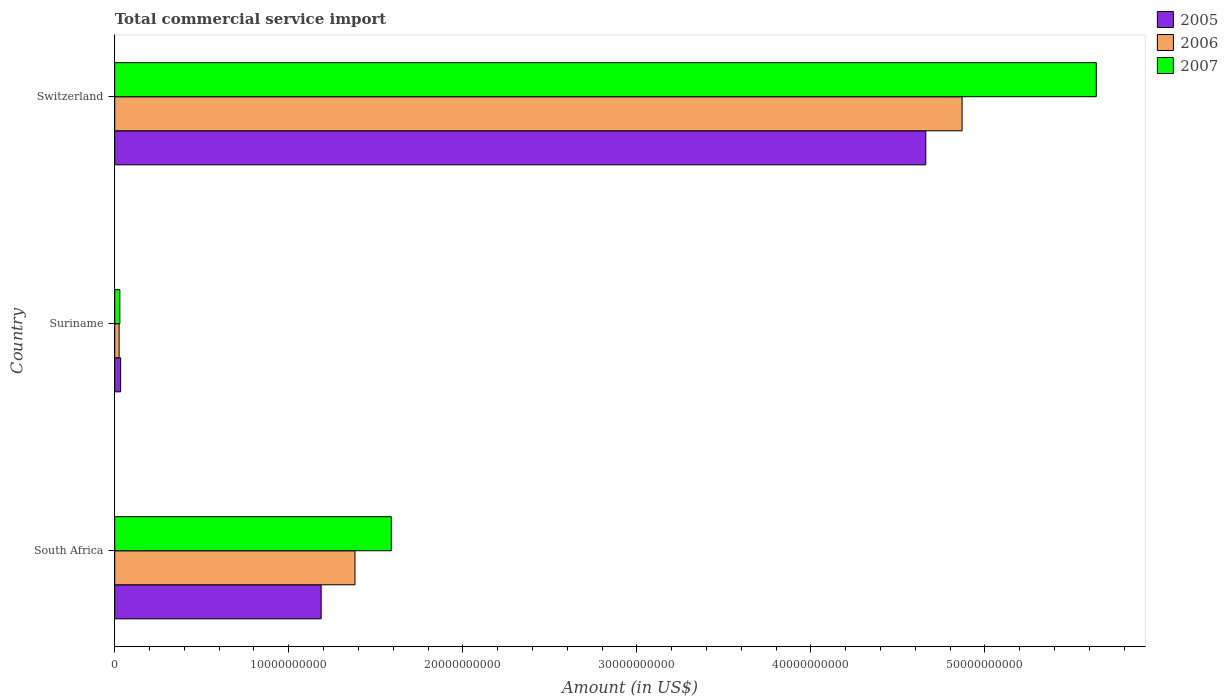How many groups of bars are there?
Your response must be concise. 3. Are the number of bars per tick equal to the number of legend labels?
Keep it short and to the point. Yes. Are the number of bars on each tick of the Y-axis equal?
Give a very brief answer. Yes. How many bars are there on the 2nd tick from the top?
Provide a short and direct response. 3. What is the label of the 1st group of bars from the top?
Give a very brief answer. Switzerland. What is the total commercial service import in 2007 in Suriname?
Your response must be concise. 2.93e+08. Across all countries, what is the maximum total commercial service import in 2006?
Offer a very short reply. 4.87e+1. Across all countries, what is the minimum total commercial service import in 2005?
Your response must be concise. 3.39e+08. In which country was the total commercial service import in 2007 maximum?
Give a very brief answer. Switzerland. In which country was the total commercial service import in 2007 minimum?
Provide a short and direct response. Suriname. What is the total total commercial service import in 2005 in the graph?
Your response must be concise. 5.88e+1. What is the difference between the total commercial service import in 2007 in South Africa and that in Switzerland?
Your response must be concise. -4.05e+1. What is the difference between the total commercial service import in 2005 in Suriname and the total commercial service import in 2006 in Switzerland?
Offer a terse response. -4.83e+1. What is the average total commercial service import in 2005 per country?
Keep it short and to the point. 1.96e+1. What is the difference between the total commercial service import in 2005 and total commercial service import in 2007 in South Africa?
Offer a terse response. -4.03e+09. What is the ratio of the total commercial service import in 2005 in South Africa to that in Suriname?
Offer a very short reply. 34.96. Is the difference between the total commercial service import in 2005 in South Africa and Switzerland greater than the difference between the total commercial service import in 2007 in South Africa and Switzerland?
Ensure brevity in your answer.  Yes. What is the difference between the highest and the second highest total commercial service import in 2007?
Your answer should be very brief. 4.05e+1. What is the difference between the highest and the lowest total commercial service import in 2006?
Your answer should be compact. 4.84e+1. What does the 3rd bar from the bottom in South Africa represents?
Give a very brief answer. 2007. How many bars are there?
Offer a terse response. 9. Are all the bars in the graph horizontal?
Provide a succinct answer. Yes. What is the difference between two consecutive major ticks on the X-axis?
Provide a short and direct response. 1.00e+1. Does the graph contain any zero values?
Your answer should be very brief. No. Does the graph contain grids?
Offer a very short reply. No. Where does the legend appear in the graph?
Your answer should be very brief. Top right. How many legend labels are there?
Your answer should be very brief. 3. What is the title of the graph?
Your answer should be very brief. Total commercial service import. Does "1989" appear as one of the legend labels in the graph?
Offer a very short reply. No. What is the label or title of the Y-axis?
Provide a succinct answer. Country. What is the Amount (in US$) of 2005 in South Africa?
Provide a short and direct response. 1.19e+1. What is the Amount (in US$) in 2006 in South Africa?
Your answer should be very brief. 1.38e+1. What is the Amount (in US$) of 2007 in South Africa?
Keep it short and to the point. 1.59e+1. What is the Amount (in US$) in 2005 in Suriname?
Your answer should be compact. 3.39e+08. What is the Amount (in US$) of 2006 in Suriname?
Your answer should be very brief. 2.51e+08. What is the Amount (in US$) of 2007 in Suriname?
Make the answer very short. 2.93e+08. What is the Amount (in US$) of 2005 in Switzerland?
Your answer should be compact. 4.66e+1. What is the Amount (in US$) in 2006 in Switzerland?
Ensure brevity in your answer.  4.87e+1. What is the Amount (in US$) in 2007 in Switzerland?
Provide a short and direct response. 5.64e+1. Across all countries, what is the maximum Amount (in US$) of 2005?
Offer a terse response. 4.66e+1. Across all countries, what is the maximum Amount (in US$) of 2006?
Your answer should be very brief. 4.87e+1. Across all countries, what is the maximum Amount (in US$) in 2007?
Provide a short and direct response. 5.64e+1. Across all countries, what is the minimum Amount (in US$) of 2005?
Provide a short and direct response. 3.39e+08. Across all countries, what is the minimum Amount (in US$) of 2006?
Offer a terse response. 2.51e+08. Across all countries, what is the minimum Amount (in US$) in 2007?
Make the answer very short. 2.93e+08. What is the total Amount (in US$) of 2005 in the graph?
Offer a very short reply. 5.88e+1. What is the total Amount (in US$) of 2006 in the graph?
Keep it short and to the point. 6.27e+1. What is the total Amount (in US$) of 2007 in the graph?
Your answer should be compact. 7.26e+1. What is the difference between the Amount (in US$) in 2005 in South Africa and that in Suriname?
Your response must be concise. 1.15e+1. What is the difference between the Amount (in US$) in 2006 in South Africa and that in Suriname?
Provide a short and direct response. 1.36e+1. What is the difference between the Amount (in US$) in 2007 in South Africa and that in Suriname?
Keep it short and to the point. 1.56e+1. What is the difference between the Amount (in US$) in 2005 in South Africa and that in Switzerland?
Ensure brevity in your answer.  -3.47e+1. What is the difference between the Amount (in US$) of 2006 in South Africa and that in Switzerland?
Offer a very short reply. -3.49e+1. What is the difference between the Amount (in US$) in 2007 in South Africa and that in Switzerland?
Give a very brief answer. -4.05e+1. What is the difference between the Amount (in US$) in 2005 in Suriname and that in Switzerland?
Offer a very short reply. -4.63e+1. What is the difference between the Amount (in US$) of 2006 in Suriname and that in Switzerland?
Your answer should be very brief. -4.84e+1. What is the difference between the Amount (in US$) of 2007 in Suriname and that in Switzerland?
Keep it short and to the point. -5.61e+1. What is the difference between the Amount (in US$) in 2005 in South Africa and the Amount (in US$) in 2006 in Suriname?
Ensure brevity in your answer.  1.16e+1. What is the difference between the Amount (in US$) of 2005 in South Africa and the Amount (in US$) of 2007 in Suriname?
Keep it short and to the point. 1.16e+1. What is the difference between the Amount (in US$) of 2006 in South Africa and the Amount (in US$) of 2007 in Suriname?
Make the answer very short. 1.35e+1. What is the difference between the Amount (in US$) of 2005 in South Africa and the Amount (in US$) of 2006 in Switzerland?
Ensure brevity in your answer.  -3.68e+1. What is the difference between the Amount (in US$) in 2005 in South Africa and the Amount (in US$) in 2007 in Switzerland?
Make the answer very short. -4.45e+1. What is the difference between the Amount (in US$) of 2006 in South Africa and the Amount (in US$) of 2007 in Switzerland?
Your response must be concise. -4.26e+1. What is the difference between the Amount (in US$) of 2005 in Suriname and the Amount (in US$) of 2006 in Switzerland?
Provide a short and direct response. -4.83e+1. What is the difference between the Amount (in US$) in 2005 in Suriname and the Amount (in US$) in 2007 in Switzerland?
Keep it short and to the point. -5.61e+1. What is the difference between the Amount (in US$) in 2006 in Suriname and the Amount (in US$) in 2007 in Switzerland?
Provide a short and direct response. -5.61e+1. What is the average Amount (in US$) of 2005 per country?
Keep it short and to the point. 1.96e+1. What is the average Amount (in US$) in 2006 per country?
Your answer should be very brief. 2.09e+1. What is the average Amount (in US$) of 2007 per country?
Offer a terse response. 2.42e+1. What is the difference between the Amount (in US$) of 2005 and Amount (in US$) of 2006 in South Africa?
Your answer should be very brief. -1.94e+09. What is the difference between the Amount (in US$) in 2005 and Amount (in US$) in 2007 in South Africa?
Offer a terse response. -4.03e+09. What is the difference between the Amount (in US$) in 2006 and Amount (in US$) in 2007 in South Africa?
Ensure brevity in your answer.  -2.09e+09. What is the difference between the Amount (in US$) in 2005 and Amount (in US$) in 2006 in Suriname?
Offer a very short reply. 8.83e+07. What is the difference between the Amount (in US$) in 2005 and Amount (in US$) in 2007 in Suriname?
Offer a very short reply. 4.63e+07. What is the difference between the Amount (in US$) of 2006 and Amount (in US$) of 2007 in Suriname?
Offer a very short reply. -4.20e+07. What is the difference between the Amount (in US$) of 2005 and Amount (in US$) of 2006 in Switzerland?
Your answer should be compact. -2.09e+09. What is the difference between the Amount (in US$) in 2005 and Amount (in US$) in 2007 in Switzerland?
Your response must be concise. -9.80e+09. What is the difference between the Amount (in US$) of 2006 and Amount (in US$) of 2007 in Switzerland?
Offer a terse response. -7.71e+09. What is the ratio of the Amount (in US$) in 2005 in South Africa to that in Suriname?
Offer a terse response. 34.96. What is the ratio of the Amount (in US$) in 2006 in South Africa to that in Suriname?
Your answer should be compact. 55.01. What is the ratio of the Amount (in US$) of 2007 in South Africa to that in Suriname?
Give a very brief answer. 54.25. What is the ratio of the Amount (in US$) of 2005 in South Africa to that in Switzerland?
Your answer should be compact. 0.25. What is the ratio of the Amount (in US$) in 2006 in South Africa to that in Switzerland?
Your answer should be very brief. 0.28. What is the ratio of the Amount (in US$) in 2007 in South Africa to that in Switzerland?
Offer a terse response. 0.28. What is the ratio of the Amount (in US$) of 2005 in Suriname to that in Switzerland?
Provide a short and direct response. 0.01. What is the ratio of the Amount (in US$) in 2006 in Suriname to that in Switzerland?
Offer a very short reply. 0.01. What is the ratio of the Amount (in US$) in 2007 in Suriname to that in Switzerland?
Make the answer very short. 0.01. What is the difference between the highest and the second highest Amount (in US$) in 2005?
Your answer should be very brief. 3.47e+1. What is the difference between the highest and the second highest Amount (in US$) of 2006?
Make the answer very short. 3.49e+1. What is the difference between the highest and the second highest Amount (in US$) in 2007?
Your answer should be very brief. 4.05e+1. What is the difference between the highest and the lowest Amount (in US$) of 2005?
Make the answer very short. 4.63e+1. What is the difference between the highest and the lowest Amount (in US$) in 2006?
Give a very brief answer. 4.84e+1. What is the difference between the highest and the lowest Amount (in US$) in 2007?
Make the answer very short. 5.61e+1. 